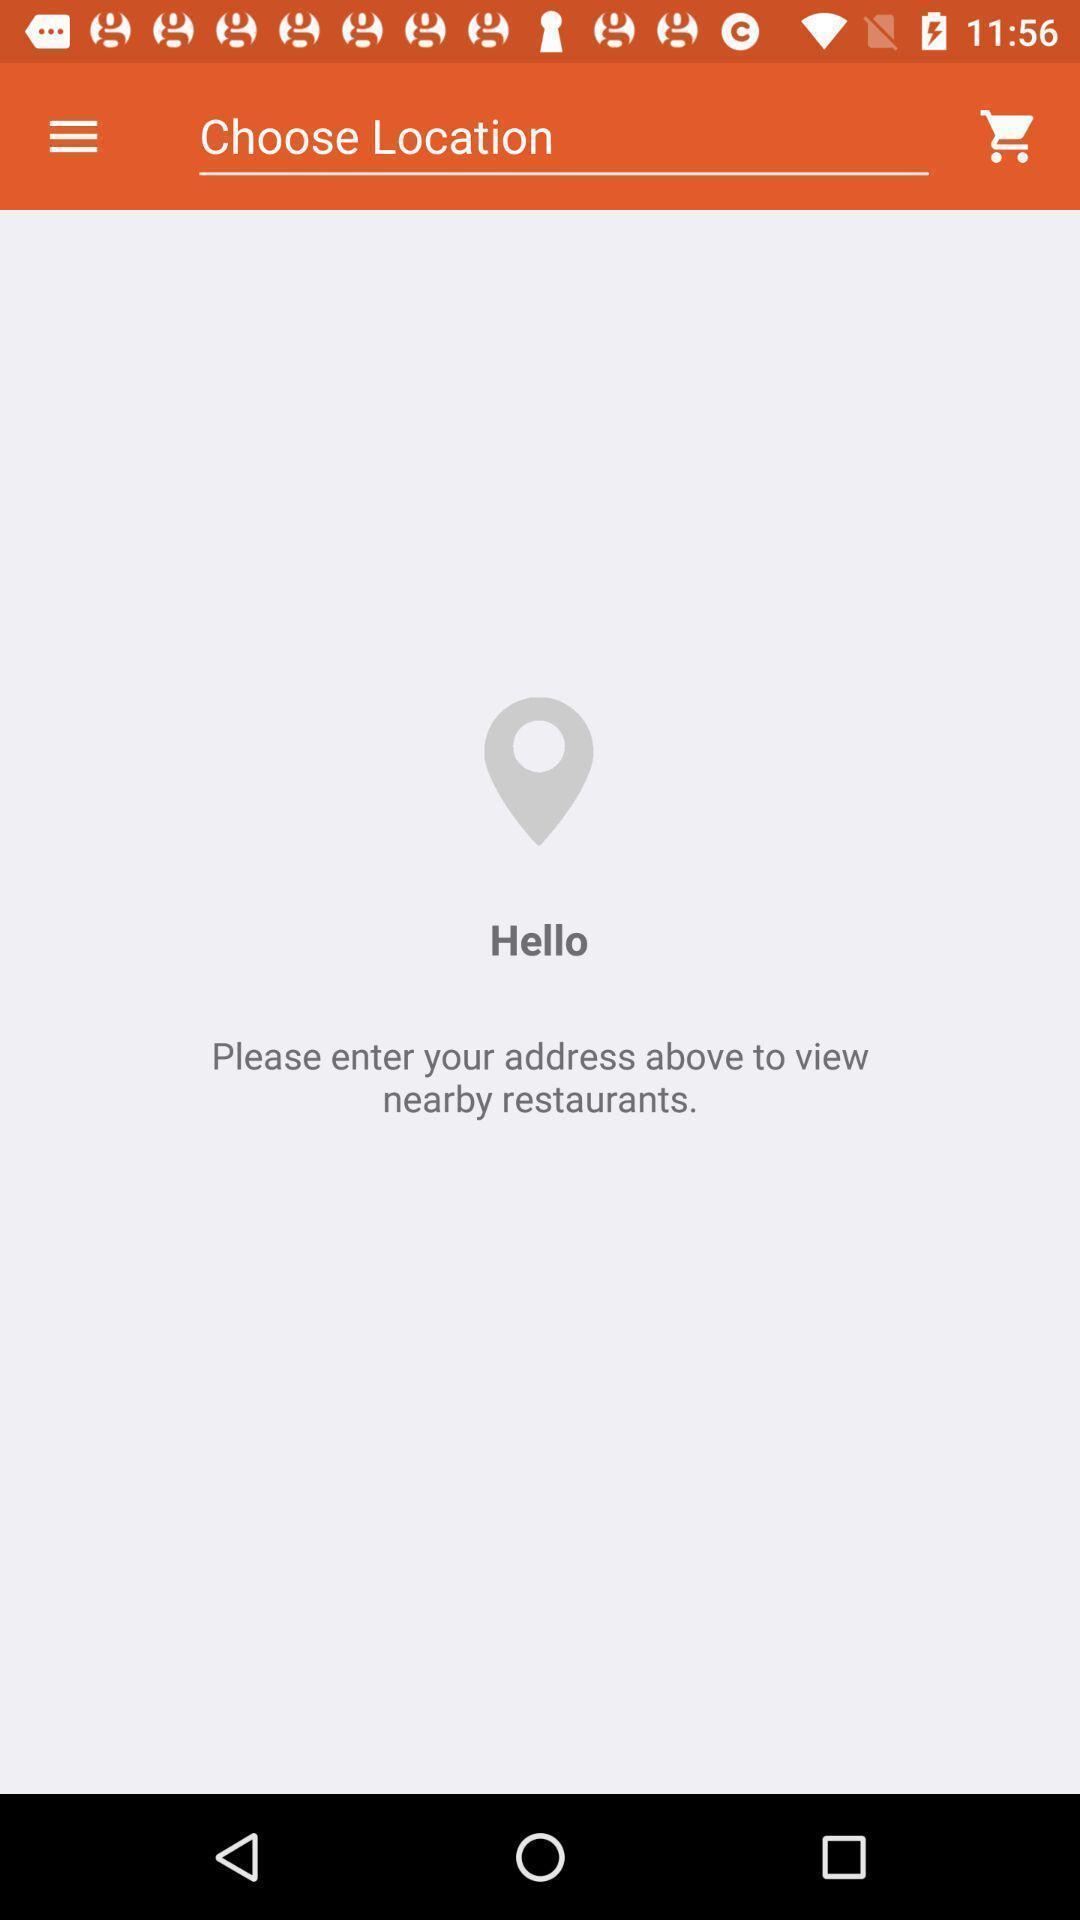What is the overall content of this screenshot? Search bar to find a restaurant in food application. 